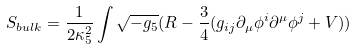Convert formula to latex. <formula><loc_0><loc_0><loc_500><loc_500>S _ { b u l k } = \frac { 1 } { 2 \kappa _ { 5 } ^ { 2 } } \int \sqrt { - g _ { 5 } } ( R - \frac { 3 } { 4 } ( g _ { i j } \partial _ { \mu } \phi ^ { i } \partial ^ { \mu } \phi ^ { j } + V ) )</formula> 